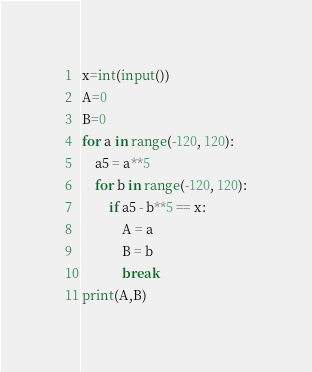Convert code to text. <code><loc_0><loc_0><loc_500><loc_500><_Python_>x=int(input())
A=0
B=0
for a in range(-120, 120):
    a5 = a**5
    for b in range(-120, 120):
        if a5 - b**5 == x:
            A = a
            B = b
            break
print(A,B)</code> 